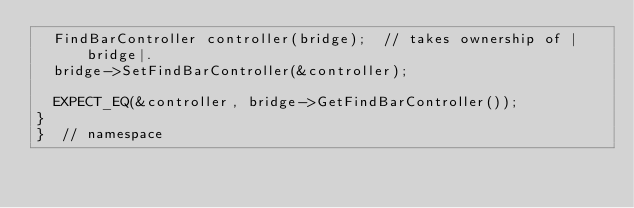<code> <loc_0><loc_0><loc_500><loc_500><_ObjectiveC_>  FindBarController controller(bridge);  // takes ownership of |bridge|.
  bridge->SetFindBarController(&controller);

  EXPECT_EQ(&controller, bridge->GetFindBarController());
}
}  // namespace
</code> 